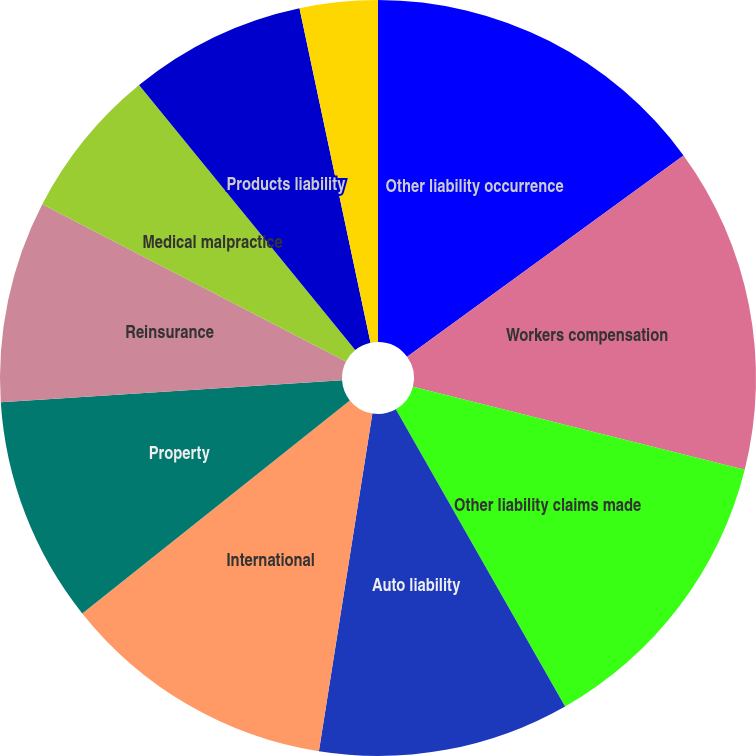<chart> <loc_0><loc_0><loc_500><loc_500><pie_chart><fcel>Other liability occurrence<fcel>Workers compensation<fcel>Other liability claims made<fcel>Auto liability<fcel>International<fcel>Property<fcel>Reinsurance<fcel>Medical malpractice<fcel>Products liability<fcel>Accident and health<nl><fcel>14.98%<fcel>13.92%<fcel>12.86%<fcel>10.74%<fcel>11.8%<fcel>9.68%<fcel>8.62%<fcel>6.51%<fcel>7.56%<fcel>3.33%<nl></chart> 